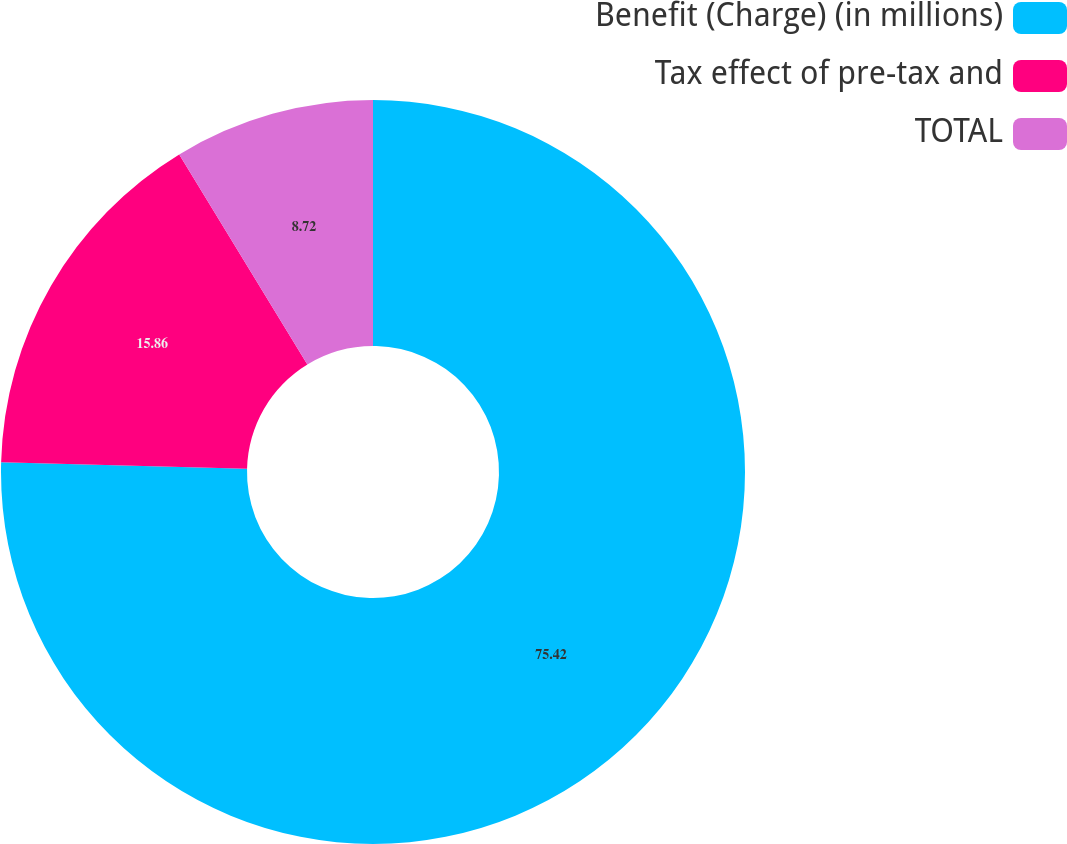Convert chart. <chart><loc_0><loc_0><loc_500><loc_500><pie_chart><fcel>Benefit (Charge) (in millions)<fcel>Tax effect of pre-tax and<fcel>TOTAL<nl><fcel>75.42%<fcel>15.86%<fcel>8.72%<nl></chart> 